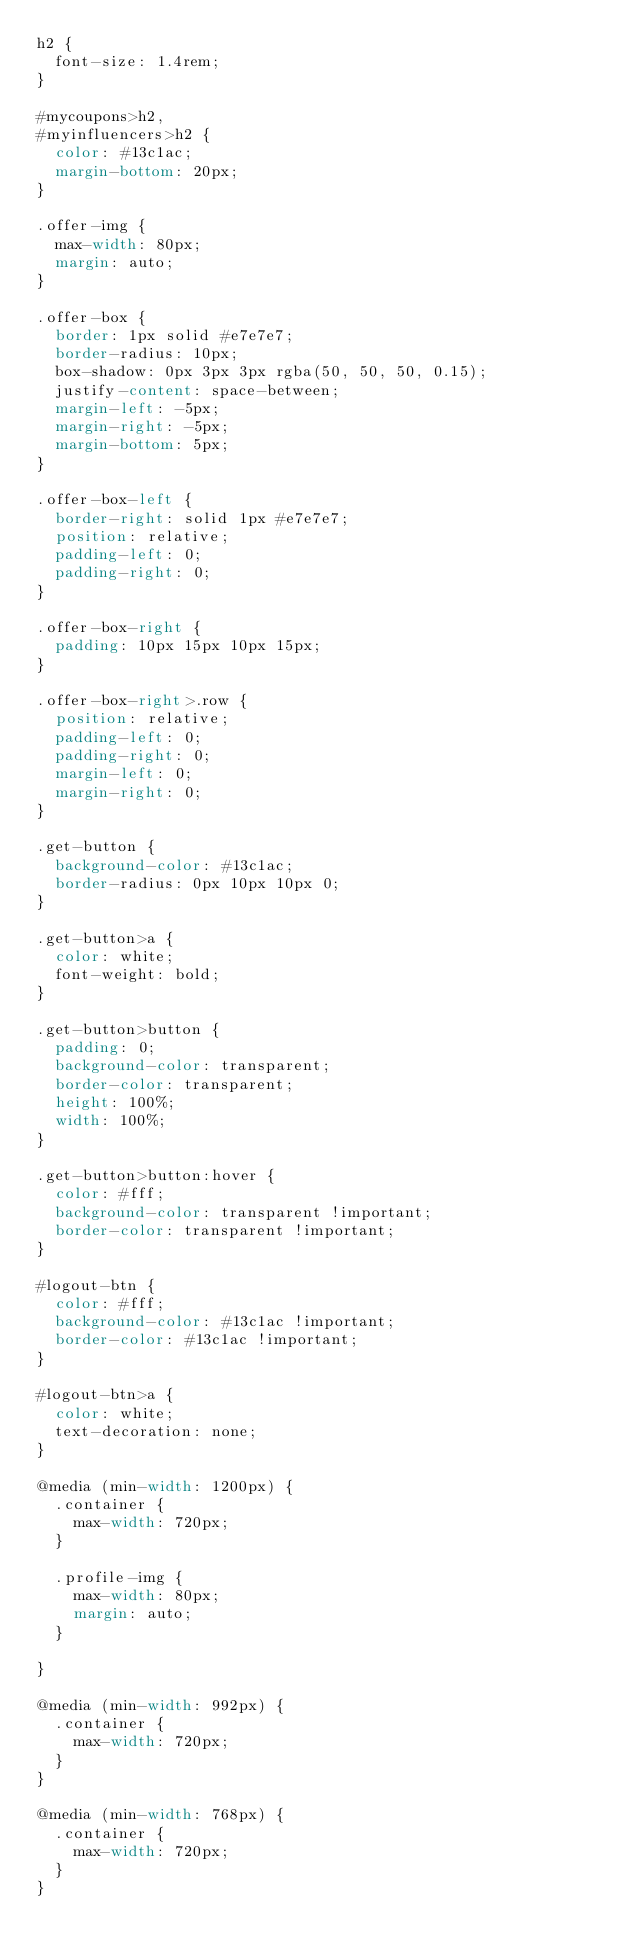<code> <loc_0><loc_0><loc_500><loc_500><_CSS_>h2 {
  font-size: 1.4rem;
}

#mycoupons>h2,
#myinfluencers>h2 {
  color: #13c1ac;
  margin-bottom: 20px;
}

.offer-img {
  max-width: 80px;
  margin: auto;
}

.offer-box {
  border: 1px solid #e7e7e7;
  border-radius: 10px;
  box-shadow: 0px 3px 3px rgba(50, 50, 50, 0.15);
  justify-content: space-between;
  margin-left: -5px;
  margin-right: -5px;
  margin-bottom: 5px;
}

.offer-box-left {
  border-right: solid 1px #e7e7e7;
  position: relative;
  padding-left: 0;
  padding-right: 0;
}

.offer-box-right {
  padding: 10px 15px 10px 15px;
}

.offer-box-right>.row {
  position: relative;
  padding-left: 0;
  padding-right: 0;
  margin-left: 0;
  margin-right: 0;
}

.get-button {
  background-color: #13c1ac;
  border-radius: 0px 10px 10px 0;
}

.get-button>a {
  color: white;
  font-weight: bold;
}

.get-button>button {
  padding: 0;
  background-color: transparent;
  border-color: transparent;
  height: 100%;
  width: 100%;
}

.get-button>button:hover {
  color: #fff;
  background-color: transparent !important;
  border-color: transparent !important;
}

#logout-btn {
  color: #fff;
  background-color: #13c1ac !important;
  border-color: #13c1ac !important;
}

#logout-btn>a {
  color: white;
  text-decoration: none;
}

@media (min-width: 1200px) {
  .container {
    max-width: 720px;
  }

  .profile-img {
    max-width: 80px;
    margin: auto;
  }

}

@media (min-width: 992px) {
  .container {
    max-width: 720px;
  }
}

@media (min-width: 768px) {
  .container {
    max-width: 720px;
  }
}

</code> 